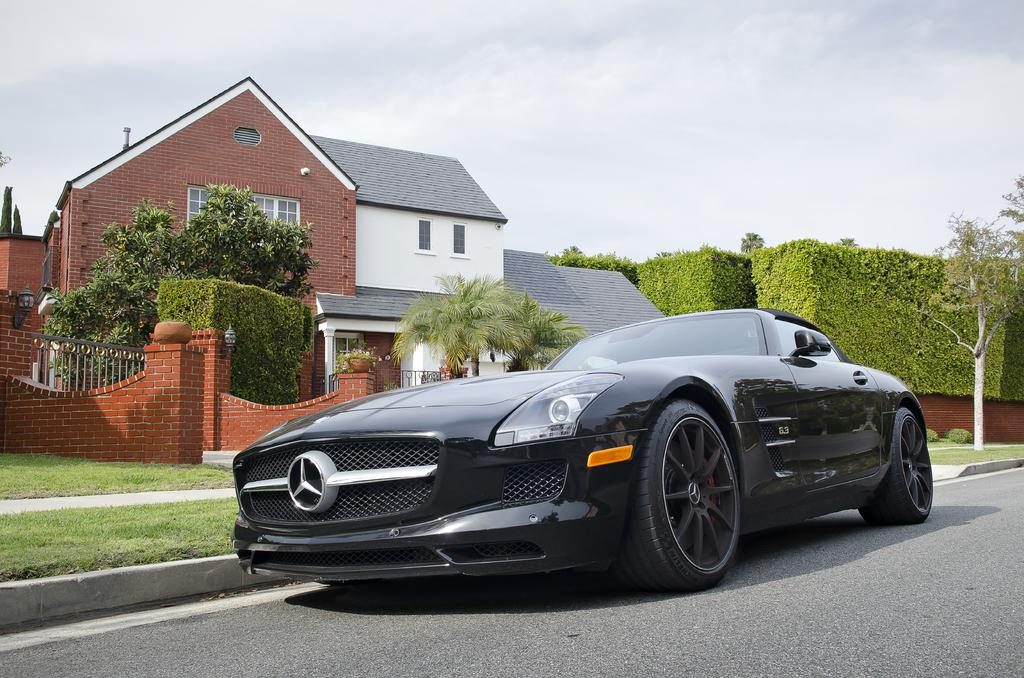What type of car is in the image? There is a black Mercedes-Benz car in the image. Where is the car located? The car is on the road. What can be seen in the background of the image? There is a house, trees, grasses, and the sky visible in the background. How many pigs are visible in the image? There are no pigs present in the image. What tool is the driver using to fix the car in the image? The image does not show the driver or any tools, so it cannot be determined what tool might be used to fix the car. 